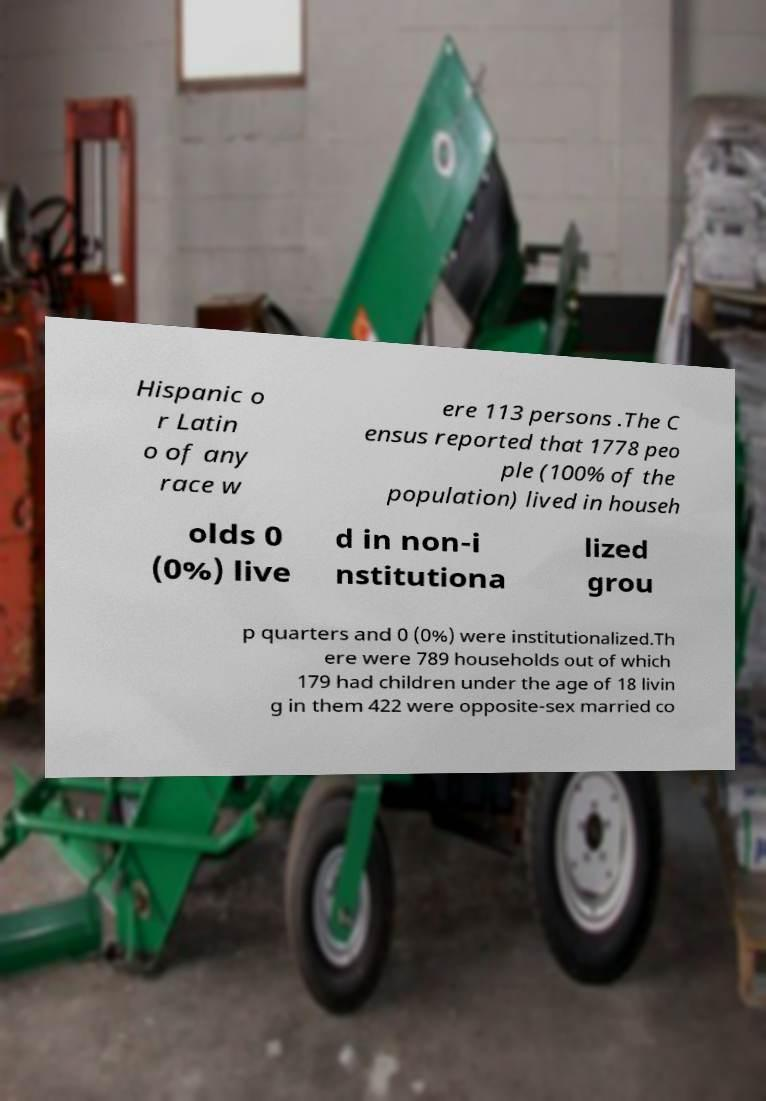Could you assist in decoding the text presented in this image and type it out clearly? Hispanic o r Latin o of any race w ere 113 persons .The C ensus reported that 1778 peo ple (100% of the population) lived in househ olds 0 (0%) live d in non-i nstitutiona lized grou p quarters and 0 (0%) were institutionalized.Th ere were 789 households out of which 179 had children under the age of 18 livin g in them 422 were opposite-sex married co 